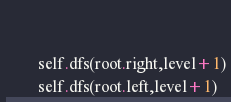Convert code to text. <code><loc_0><loc_0><loc_500><loc_500><_Python_>    
        
        self.dfs(root.right,level+1)
        self.dfs(root.left,level+1)</code> 